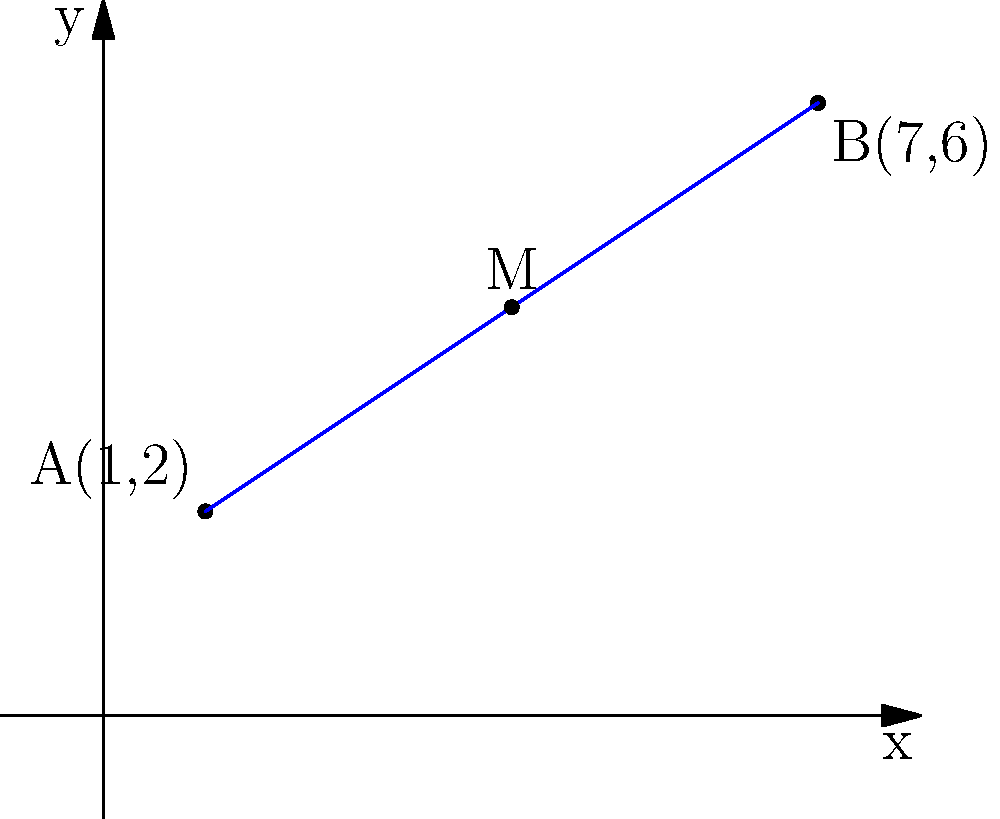In the journey of life, finding balance is crucial. Consider two life decisions represented by points A(1,2) and B(7,6) on a coordinate plane. If you were to find a middle ground between these two choices, represented by the midpoint M, what would be its coordinates? How might this concept of finding a midpoint relate to achieving balance in life decisions? To find the midpoint M between two points A(1,2) and B(7,6), we can follow these steps:

1. Identify the coordinates:
   Point A: $(x_1, y_1) = (1, 2)$
   Point B: $(x_2, y_2) = (7, 6)$

2. Use the midpoint formula:
   The midpoint formula is: $M(\frac{x_1 + x_2}{2}, \frac{y_1 + y_2}{2})$

3. Calculate the x-coordinate of the midpoint:
   $x_M = \frac{x_1 + x_2}{2} = \frac{1 + 7}{2} = \frac{8}{2} = 4$

4. Calculate the y-coordinate of the midpoint:
   $y_M = \frac{y_1 + y_2}{2} = \frac{2 + 6}{2} = \frac{8}{2} = 4$

5. Combine the results:
   The midpoint M has coordinates (4, 4)

In the context of life decisions, finding the midpoint can represent finding a balance between two extremes. Just as the midpoint is equidistant from both original points, a balanced decision often involves considering and partially incorporating aspects of different options. This approach can lead to more nuanced and well-rounded choices in life.
Answer: M(4, 4) 